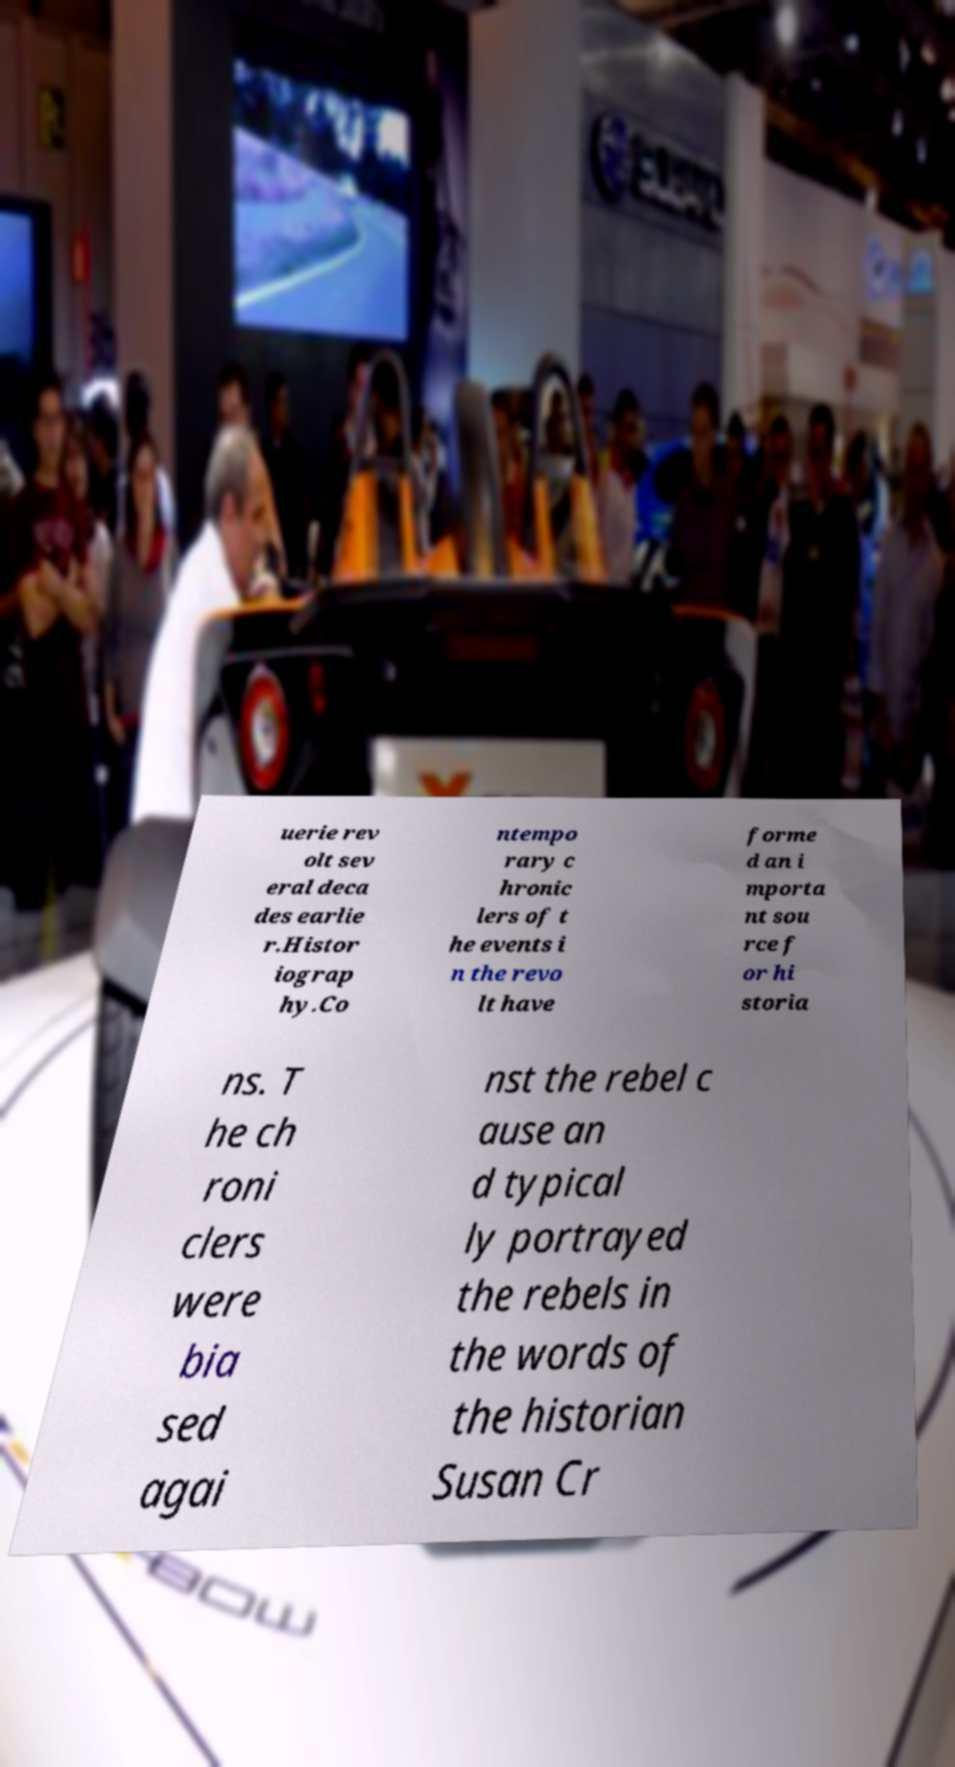Could you extract and type out the text from this image? uerie rev olt sev eral deca des earlie r.Histor iograp hy.Co ntempo rary c hronic lers of t he events i n the revo lt have forme d an i mporta nt sou rce f or hi storia ns. T he ch roni clers were bia sed agai nst the rebel c ause an d typical ly portrayed the rebels in the words of the historian Susan Cr 